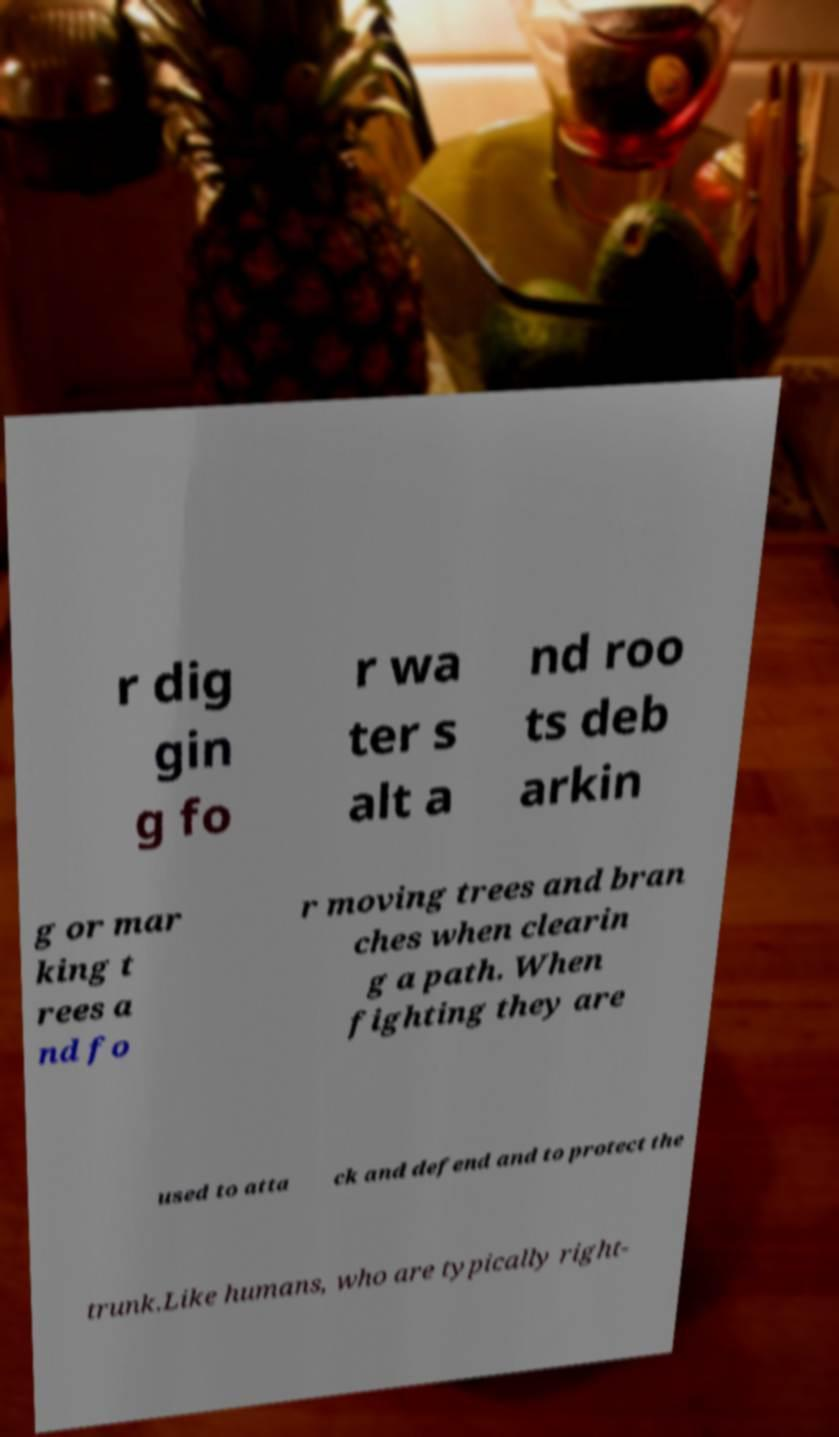Can you accurately transcribe the text from the provided image for me? r dig gin g fo r wa ter s alt a nd roo ts deb arkin g or mar king t rees a nd fo r moving trees and bran ches when clearin g a path. When fighting they are used to atta ck and defend and to protect the trunk.Like humans, who are typically right- 